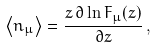<formula> <loc_0><loc_0><loc_500><loc_500>\left < n _ { \mu } \right > = \frac { z \, \partial \ln F _ { \mu } ( z ) } { \partial z } \, ,</formula> 